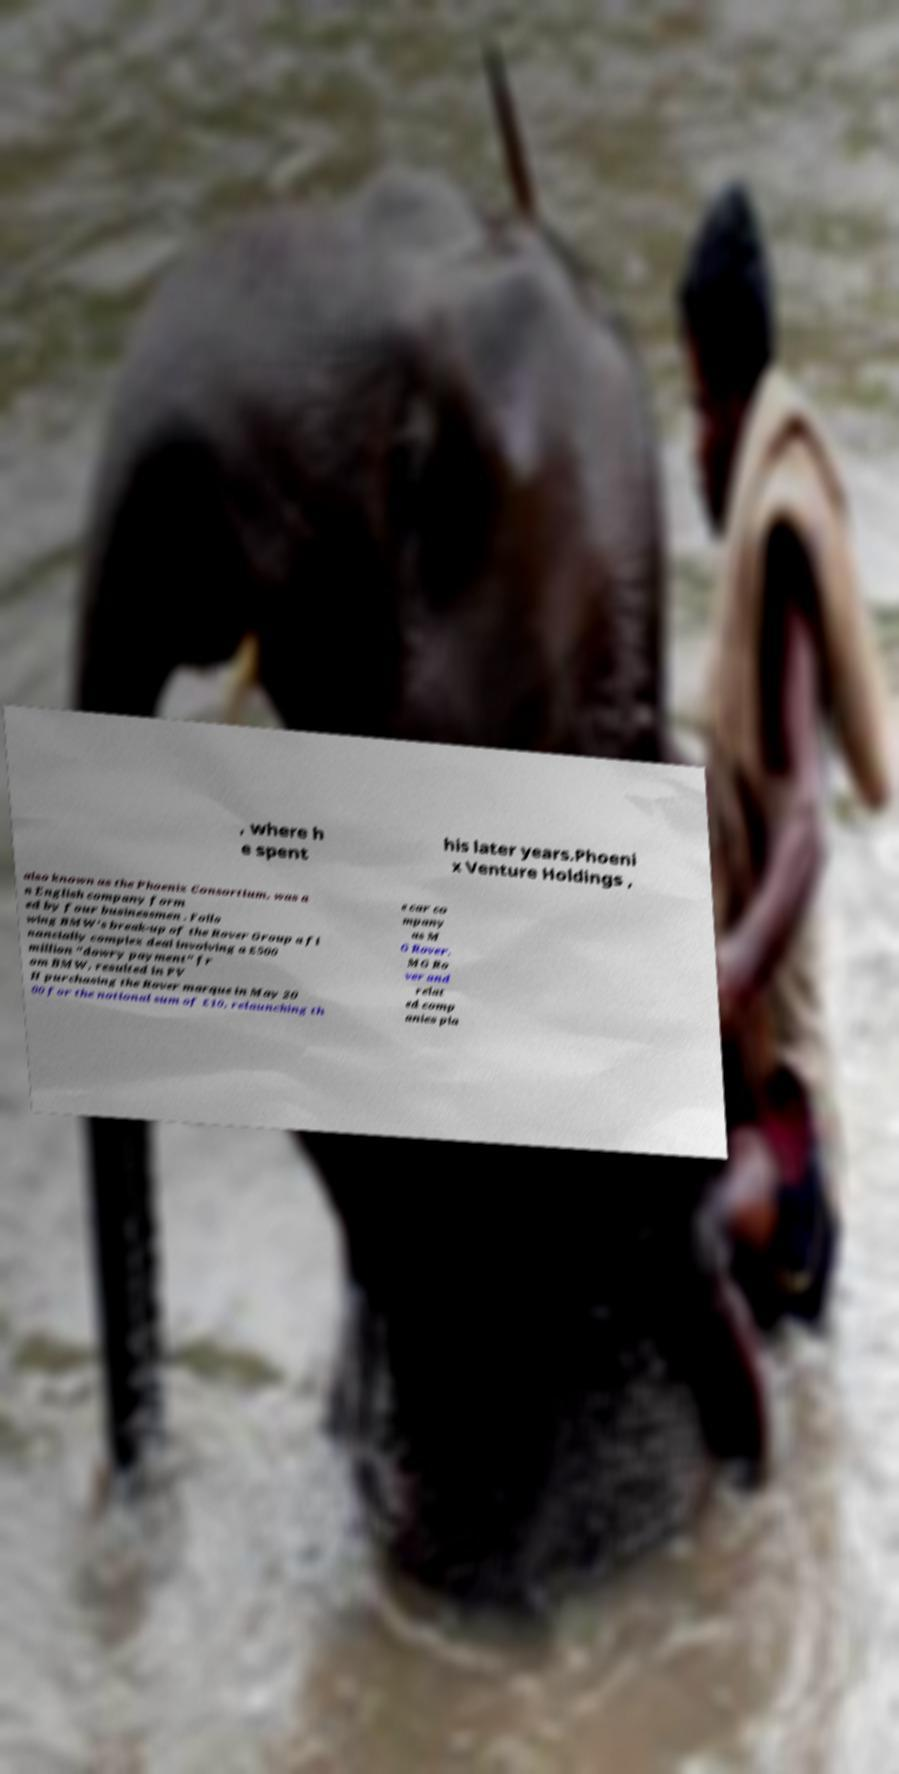What messages or text are displayed in this image? I need them in a readable, typed format. , where h e spent his later years.Phoeni x Venture Holdings , also known as the Phoenix Consortium, was a n English company form ed by four businessmen . Follo wing BMW's break-up of the Rover Group a fi nancially complex deal involving a £500 million "dowry payment" fr om BMW, resulted in PV H purchasing the Rover marque in May 20 00 for the notional sum of £10, relaunching th e car co mpany as M G Rover. MG Ro ver and relat ed comp anies pla 